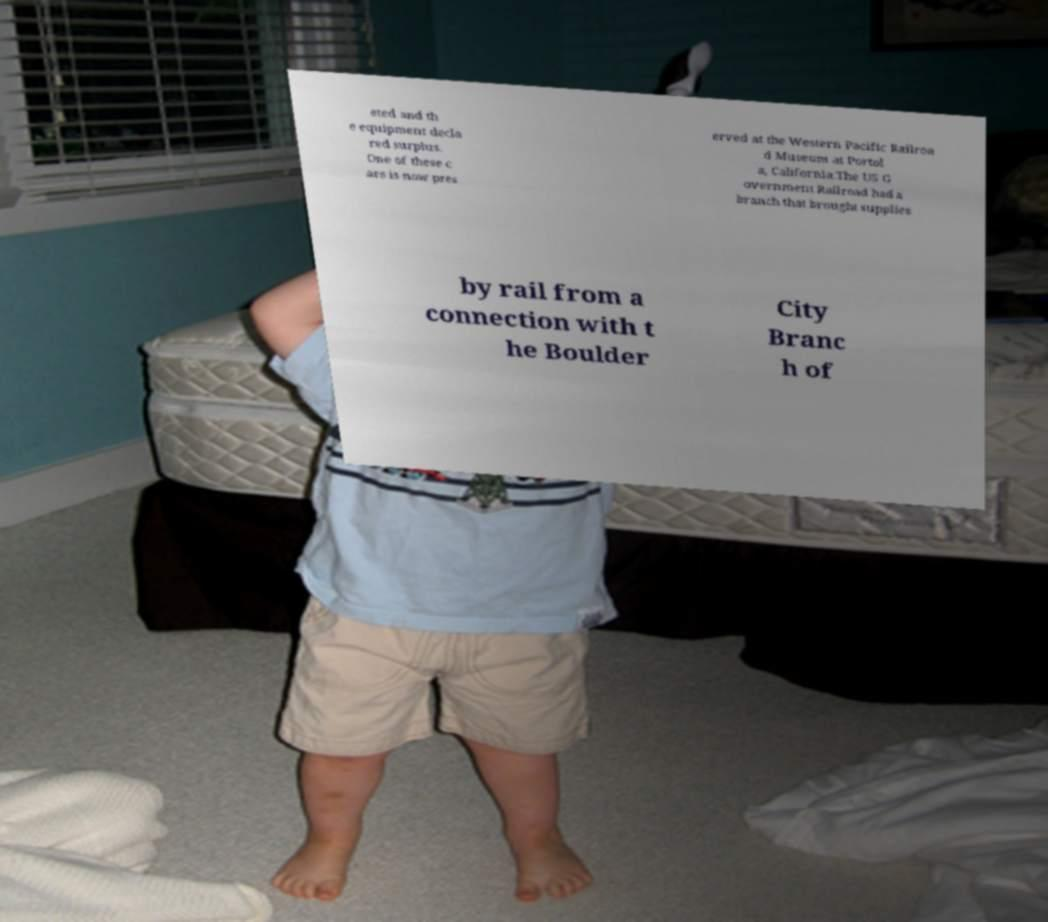Could you extract and type out the text from this image? eted and th e equipment decla red surplus. One of these c ars is now pres erved at the Western Pacific Railroa d Museum at Portol a, California.The US G overnment Railroad had a branch that brought supplies by rail from a connection with t he Boulder City Branc h of 